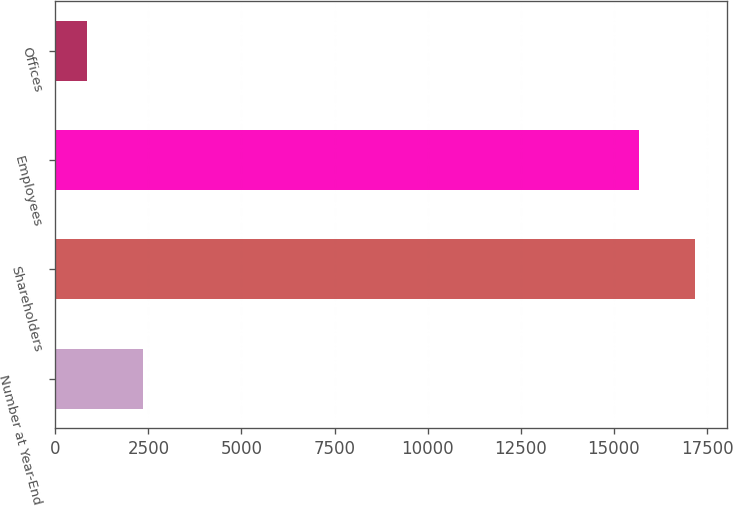<chart> <loc_0><loc_0><loc_500><loc_500><bar_chart><fcel>Number at Year-End<fcel>Shareholders<fcel>Employees<fcel>Offices<nl><fcel>2360<fcel>17177<fcel>15666<fcel>849<nl></chart> 